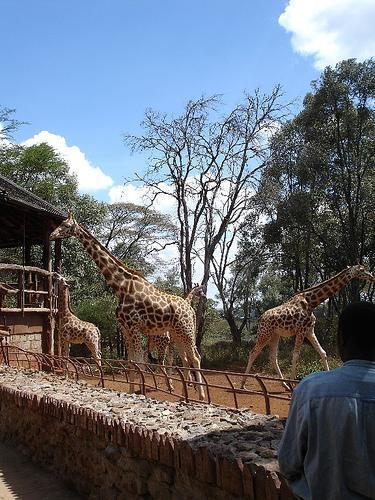How many giraffes are visible?
Give a very brief answer. 3. 